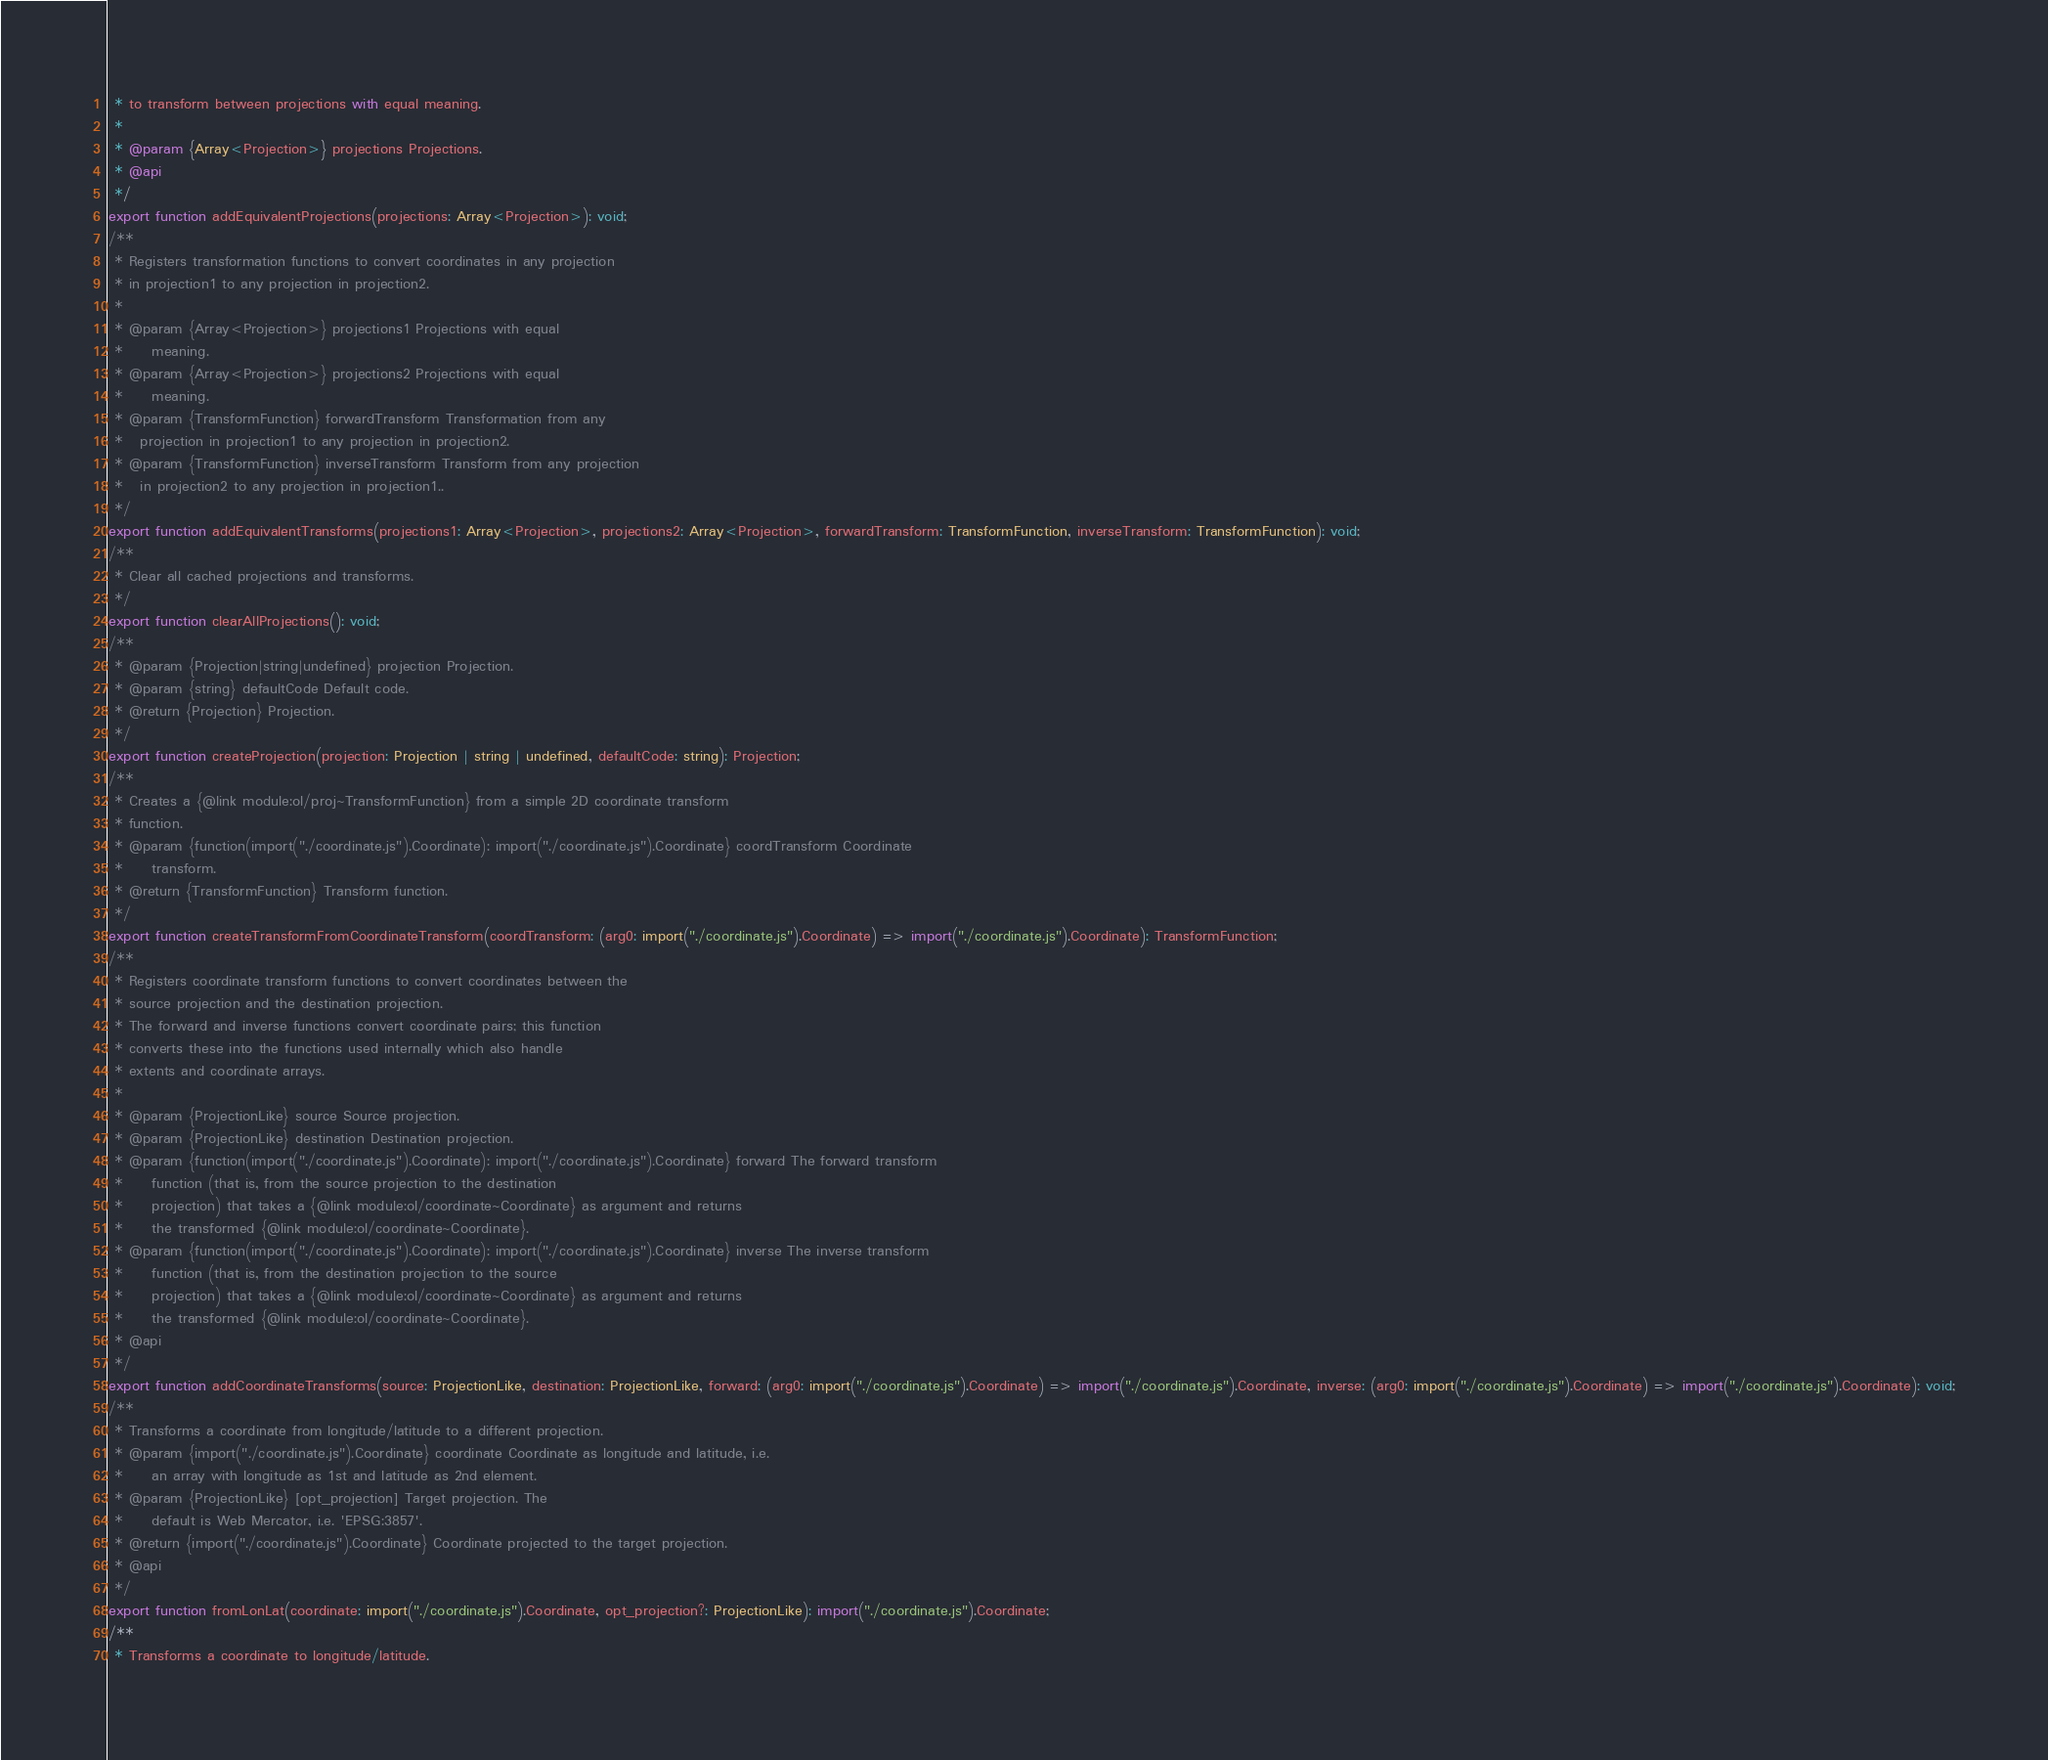<code> <loc_0><loc_0><loc_500><loc_500><_TypeScript_> * to transform between projections with equal meaning.
 *
 * @param {Array<Projection>} projections Projections.
 * @api
 */
export function addEquivalentProjections(projections: Array<Projection>): void;
/**
 * Registers transformation functions to convert coordinates in any projection
 * in projection1 to any projection in projection2.
 *
 * @param {Array<Projection>} projections1 Projections with equal
 *     meaning.
 * @param {Array<Projection>} projections2 Projections with equal
 *     meaning.
 * @param {TransformFunction} forwardTransform Transformation from any
 *   projection in projection1 to any projection in projection2.
 * @param {TransformFunction} inverseTransform Transform from any projection
 *   in projection2 to any projection in projection1..
 */
export function addEquivalentTransforms(projections1: Array<Projection>, projections2: Array<Projection>, forwardTransform: TransformFunction, inverseTransform: TransformFunction): void;
/**
 * Clear all cached projections and transforms.
 */
export function clearAllProjections(): void;
/**
 * @param {Projection|string|undefined} projection Projection.
 * @param {string} defaultCode Default code.
 * @return {Projection} Projection.
 */
export function createProjection(projection: Projection | string | undefined, defaultCode: string): Projection;
/**
 * Creates a {@link module:ol/proj~TransformFunction} from a simple 2D coordinate transform
 * function.
 * @param {function(import("./coordinate.js").Coordinate): import("./coordinate.js").Coordinate} coordTransform Coordinate
 *     transform.
 * @return {TransformFunction} Transform function.
 */
export function createTransformFromCoordinateTransform(coordTransform: (arg0: import("./coordinate.js").Coordinate) => import("./coordinate.js").Coordinate): TransformFunction;
/**
 * Registers coordinate transform functions to convert coordinates between the
 * source projection and the destination projection.
 * The forward and inverse functions convert coordinate pairs; this function
 * converts these into the functions used internally which also handle
 * extents and coordinate arrays.
 *
 * @param {ProjectionLike} source Source projection.
 * @param {ProjectionLike} destination Destination projection.
 * @param {function(import("./coordinate.js").Coordinate): import("./coordinate.js").Coordinate} forward The forward transform
 *     function (that is, from the source projection to the destination
 *     projection) that takes a {@link module:ol/coordinate~Coordinate} as argument and returns
 *     the transformed {@link module:ol/coordinate~Coordinate}.
 * @param {function(import("./coordinate.js").Coordinate): import("./coordinate.js").Coordinate} inverse The inverse transform
 *     function (that is, from the destination projection to the source
 *     projection) that takes a {@link module:ol/coordinate~Coordinate} as argument and returns
 *     the transformed {@link module:ol/coordinate~Coordinate}.
 * @api
 */
export function addCoordinateTransforms(source: ProjectionLike, destination: ProjectionLike, forward: (arg0: import("./coordinate.js").Coordinate) => import("./coordinate.js").Coordinate, inverse: (arg0: import("./coordinate.js").Coordinate) => import("./coordinate.js").Coordinate): void;
/**
 * Transforms a coordinate from longitude/latitude to a different projection.
 * @param {import("./coordinate.js").Coordinate} coordinate Coordinate as longitude and latitude, i.e.
 *     an array with longitude as 1st and latitude as 2nd element.
 * @param {ProjectionLike} [opt_projection] Target projection. The
 *     default is Web Mercator, i.e. 'EPSG:3857'.
 * @return {import("./coordinate.js").Coordinate} Coordinate projected to the target projection.
 * @api
 */
export function fromLonLat(coordinate: import("./coordinate.js").Coordinate, opt_projection?: ProjectionLike): import("./coordinate.js").Coordinate;
/**
 * Transforms a coordinate to longitude/latitude.</code> 